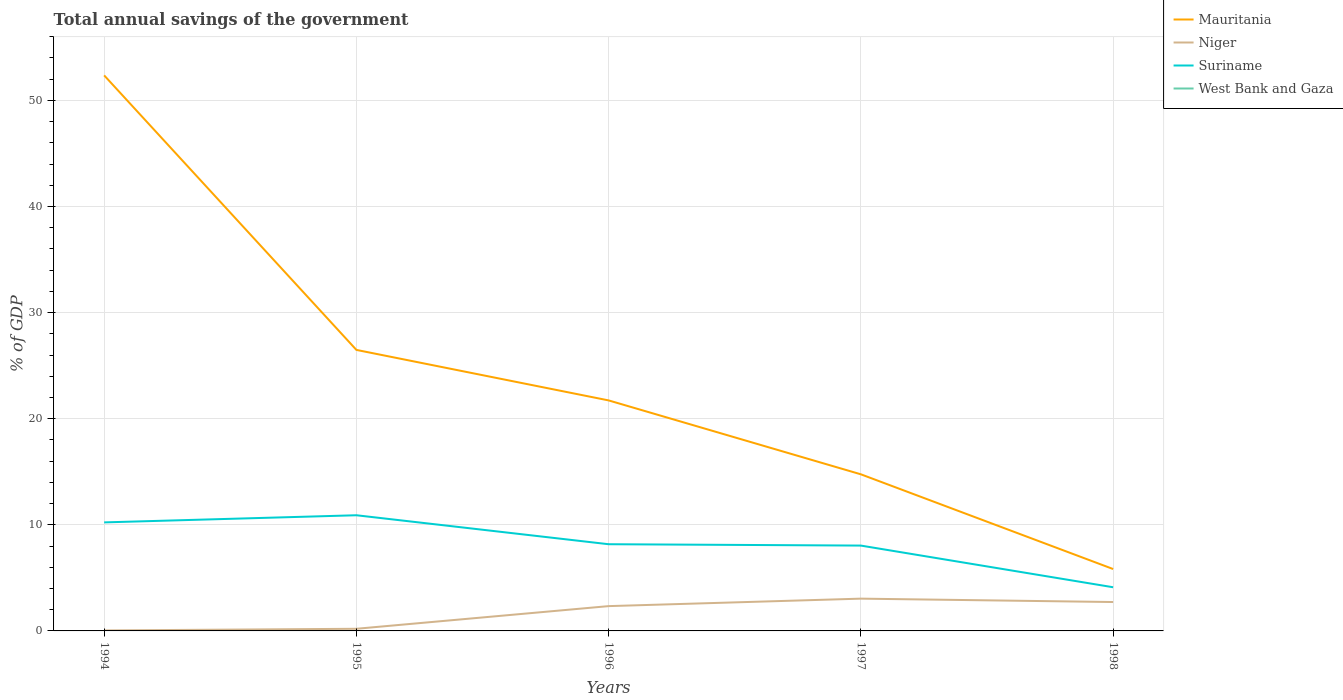How many different coloured lines are there?
Your response must be concise. 3. Across all years, what is the maximum total annual savings of the government in Suriname?
Your answer should be very brief. 4.12. What is the total total annual savings of the government in Suriname in the graph?
Offer a very short reply. 2.73. What is the difference between the highest and the second highest total annual savings of the government in Niger?
Offer a very short reply. 3. Is the total annual savings of the government in Mauritania strictly greater than the total annual savings of the government in Suriname over the years?
Provide a succinct answer. No. What is the difference between two consecutive major ticks on the Y-axis?
Offer a very short reply. 10. Are the values on the major ticks of Y-axis written in scientific E-notation?
Offer a very short reply. No. Does the graph contain any zero values?
Your answer should be very brief. Yes. How many legend labels are there?
Your answer should be very brief. 4. How are the legend labels stacked?
Ensure brevity in your answer.  Vertical. What is the title of the graph?
Keep it short and to the point. Total annual savings of the government. What is the label or title of the X-axis?
Offer a very short reply. Years. What is the label or title of the Y-axis?
Ensure brevity in your answer.  % of GDP. What is the % of GDP in Mauritania in 1994?
Provide a succinct answer. 52.35. What is the % of GDP in Niger in 1994?
Provide a succinct answer. 0.05. What is the % of GDP in Suriname in 1994?
Provide a succinct answer. 10.23. What is the % of GDP of Mauritania in 1995?
Ensure brevity in your answer.  26.48. What is the % of GDP in Niger in 1995?
Provide a succinct answer. 0.2. What is the % of GDP of Suriname in 1995?
Give a very brief answer. 10.9. What is the % of GDP in Mauritania in 1996?
Ensure brevity in your answer.  21.72. What is the % of GDP in Niger in 1996?
Keep it short and to the point. 2.34. What is the % of GDP of Suriname in 1996?
Your response must be concise. 8.17. What is the % of GDP in Mauritania in 1997?
Offer a very short reply. 14.76. What is the % of GDP of Niger in 1997?
Make the answer very short. 3.04. What is the % of GDP in Suriname in 1997?
Offer a very short reply. 8.04. What is the % of GDP of West Bank and Gaza in 1997?
Offer a terse response. 0. What is the % of GDP of Mauritania in 1998?
Offer a terse response. 5.83. What is the % of GDP in Niger in 1998?
Keep it short and to the point. 2.72. What is the % of GDP of Suriname in 1998?
Your response must be concise. 4.12. Across all years, what is the maximum % of GDP of Mauritania?
Keep it short and to the point. 52.35. Across all years, what is the maximum % of GDP in Niger?
Offer a very short reply. 3.04. Across all years, what is the maximum % of GDP in Suriname?
Make the answer very short. 10.9. Across all years, what is the minimum % of GDP of Mauritania?
Your answer should be compact. 5.83. Across all years, what is the minimum % of GDP in Niger?
Your answer should be compact. 0.05. Across all years, what is the minimum % of GDP of Suriname?
Your answer should be very brief. 4.12. What is the total % of GDP in Mauritania in the graph?
Your response must be concise. 121.15. What is the total % of GDP in Niger in the graph?
Keep it short and to the point. 8.35. What is the total % of GDP in Suriname in the graph?
Provide a short and direct response. 41.46. What is the difference between the % of GDP of Mauritania in 1994 and that in 1995?
Your response must be concise. 25.87. What is the difference between the % of GDP in Niger in 1994 and that in 1995?
Your answer should be compact. -0.16. What is the difference between the % of GDP in Suriname in 1994 and that in 1995?
Give a very brief answer. -0.67. What is the difference between the % of GDP of Mauritania in 1994 and that in 1996?
Make the answer very short. 30.63. What is the difference between the % of GDP in Niger in 1994 and that in 1996?
Provide a succinct answer. -2.29. What is the difference between the % of GDP of Suriname in 1994 and that in 1996?
Keep it short and to the point. 2.06. What is the difference between the % of GDP of Mauritania in 1994 and that in 1997?
Your answer should be very brief. 37.59. What is the difference between the % of GDP in Niger in 1994 and that in 1997?
Give a very brief answer. -3. What is the difference between the % of GDP of Suriname in 1994 and that in 1997?
Your answer should be very brief. 2.19. What is the difference between the % of GDP in Mauritania in 1994 and that in 1998?
Give a very brief answer. 46.52. What is the difference between the % of GDP of Niger in 1994 and that in 1998?
Your response must be concise. -2.68. What is the difference between the % of GDP in Suriname in 1994 and that in 1998?
Ensure brevity in your answer.  6.11. What is the difference between the % of GDP in Mauritania in 1995 and that in 1996?
Make the answer very short. 4.76. What is the difference between the % of GDP of Niger in 1995 and that in 1996?
Keep it short and to the point. -2.14. What is the difference between the % of GDP of Suriname in 1995 and that in 1996?
Your answer should be compact. 2.73. What is the difference between the % of GDP in Mauritania in 1995 and that in 1997?
Your answer should be very brief. 11.72. What is the difference between the % of GDP of Niger in 1995 and that in 1997?
Your response must be concise. -2.84. What is the difference between the % of GDP in Suriname in 1995 and that in 1997?
Provide a short and direct response. 2.86. What is the difference between the % of GDP in Mauritania in 1995 and that in 1998?
Provide a succinct answer. 20.65. What is the difference between the % of GDP of Niger in 1995 and that in 1998?
Provide a short and direct response. -2.52. What is the difference between the % of GDP in Suriname in 1995 and that in 1998?
Provide a succinct answer. 6.79. What is the difference between the % of GDP in Mauritania in 1996 and that in 1997?
Your answer should be very brief. 6.96. What is the difference between the % of GDP in Niger in 1996 and that in 1997?
Provide a succinct answer. -0.71. What is the difference between the % of GDP of Suriname in 1996 and that in 1997?
Offer a terse response. 0.13. What is the difference between the % of GDP in Mauritania in 1996 and that in 1998?
Your answer should be compact. 15.89. What is the difference between the % of GDP in Niger in 1996 and that in 1998?
Give a very brief answer. -0.39. What is the difference between the % of GDP of Suriname in 1996 and that in 1998?
Your response must be concise. 4.05. What is the difference between the % of GDP in Mauritania in 1997 and that in 1998?
Your answer should be compact. 8.93. What is the difference between the % of GDP in Niger in 1997 and that in 1998?
Keep it short and to the point. 0.32. What is the difference between the % of GDP in Suriname in 1997 and that in 1998?
Ensure brevity in your answer.  3.93. What is the difference between the % of GDP in Mauritania in 1994 and the % of GDP in Niger in 1995?
Offer a terse response. 52.15. What is the difference between the % of GDP in Mauritania in 1994 and the % of GDP in Suriname in 1995?
Keep it short and to the point. 41.45. What is the difference between the % of GDP of Niger in 1994 and the % of GDP of Suriname in 1995?
Provide a succinct answer. -10.86. What is the difference between the % of GDP in Mauritania in 1994 and the % of GDP in Niger in 1996?
Your response must be concise. 50.01. What is the difference between the % of GDP in Mauritania in 1994 and the % of GDP in Suriname in 1996?
Your response must be concise. 44.18. What is the difference between the % of GDP of Niger in 1994 and the % of GDP of Suriname in 1996?
Provide a succinct answer. -8.13. What is the difference between the % of GDP of Mauritania in 1994 and the % of GDP of Niger in 1997?
Your answer should be compact. 49.31. What is the difference between the % of GDP in Mauritania in 1994 and the % of GDP in Suriname in 1997?
Your response must be concise. 44.31. What is the difference between the % of GDP of Niger in 1994 and the % of GDP of Suriname in 1997?
Your answer should be compact. -8. What is the difference between the % of GDP of Mauritania in 1994 and the % of GDP of Niger in 1998?
Provide a short and direct response. 49.63. What is the difference between the % of GDP of Mauritania in 1994 and the % of GDP of Suriname in 1998?
Offer a very short reply. 48.24. What is the difference between the % of GDP of Niger in 1994 and the % of GDP of Suriname in 1998?
Make the answer very short. -4.07. What is the difference between the % of GDP in Mauritania in 1995 and the % of GDP in Niger in 1996?
Keep it short and to the point. 24.14. What is the difference between the % of GDP of Mauritania in 1995 and the % of GDP of Suriname in 1996?
Ensure brevity in your answer.  18.31. What is the difference between the % of GDP in Niger in 1995 and the % of GDP in Suriname in 1996?
Ensure brevity in your answer.  -7.97. What is the difference between the % of GDP of Mauritania in 1995 and the % of GDP of Niger in 1997?
Offer a terse response. 23.44. What is the difference between the % of GDP of Mauritania in 1995 and the % of GDP of Suriname in 1997?
Provide a succinct answer. 18.44. What is the difference between the % of GDP in Niger in 1995 and the % of GDP in Suriname in 1997?
Provide a succinct answer. -7.84. What is the difference between the % of GDP of Mauritania in 1995 and the % of GDP of Niger in 1998?
Ensure brevity in your answer.  23.76. What is the difference between the % of GDP in Mauritania in 1995 and the % of GDP in Suriname in 1998?
Your answer should be compact. 22.37. What is the difference between the % of GDP of Niger in 1995 and the % of GDP of Suriname in 1998?
Your answer should be very brief. -3.91. What is the difference between the % of GDP of Mauritania in 1996 and the % of GDP of Niger in 1997?
Offer a terse response. 18.68. What is the difference between the % of GDP in Mauritania in 1996 and the % of GDP in Suriname in 1997?
Offer a terse response. 13.68. What is the difference between the % of GDP of Niger in 1996 and the % of GDP of Suriname in 1997?
Keep it short and to the point. -5.7. What is the difference between the % of GDP of Mauritania in 1996 and the % of GDP of Niger in 1998?
Your response must be concise. 19. What is the difference between the % of GDP of Mauritania in 1996 and the % of GDP of Suriname in 1998?
Your response must be concise. 17.61. What is the difference between the % of GDP of Niger in 1996 and the % of GDP of Suriname in 1998?
Offer a very short reply. -1.78. What is the difference between the % of GDP of Mauritania in 1997 and the % of GDP of Niger in 1998?
Offer a very short reply. 12.03. What is the difference between the % of GDP of Mauritania in 1997 and the % of GDP of Suriname in 1998?
Give a very brief answer. 10.64. What is the difference between the % of GDP in Niger in 1997 and the % of GDP in Suriname in 1998?
Offer a very short reply. -1.07. What is the average % of GDP in Mauritania per year?
Your answer should be compact. 24.23. What is the average % of GDP in Niger per year?
Give a very brief answer. 1.67. What is the average % of GDP in Suriname per year?
Provide a succinct answer. 8.29. In the year 1994, what is the difference between the % of GDP in Mauritania and % of GDP in Niger?
Give a very brief answer. 52.31. In the year 1994, what is the difference between the % of GDP of Mauritania and % of GDP of Suriname?
Offer a very short reply. 42.12. In the year 1994, what is the difference between the % of GDP in Niger and % of GDP in Suriname?
Make the answer very short. -10.18. In the year 1995, what is the difference between the % of GDP of Mauritania and % of GDP of Niger?
Give a very brief answer. 26.28. In the year 1995, what is the difference between the % of GDP in Mauritania and % of GDP in Suriname?
Keep it short and to the point. 15.58. In the year 1995, what is the difference between the % of GDP of Niger and % of GDP of Suriname?
Offer a terse response. -10.7. In the year 1996, what is the difference between the % of GDP in Mauritania and % of GDP in Niger?
Provide a succinct answer. 19.38. In the year 1996, what is the difference between the % of GDP in Mauritania and % of GDP in Suriname?
Provide a short and direct response. 13.55. In the year 1996, what is the difference between the % of GDP in Niger and % of GDP in Suriname?
Your response must be concise. -5.83. In the year 1997, what is the difference between the % of GDP of Mauritania and % of GDP of Niger?
Give a very brief answer. 11.72. In the year 1997, what is the difference between the % of GDP in Mauritania and % of GDP in Suriname?
Keep it short and to the point. 6.72. In the year 1997, what is the difference between the % of GDP in Niger and % of GDP in Suriname?
Provide a succinct answer. -5. In the year 1998, what is the difference between the % of GDP in Mauritania and % of GDP in Niger?
Your answer should be compact. 3.11. In the year 1998, what is the difference between the % of GDP of Mauritania and % of GDP of Suriname?
Your answer should be very brief. 1.72. In the year 1998, what is the difference between the % of GDP in Niger and % of GDP in Suriname?
Your response must be concise. -1.39. What is the ratio of the % of GDP of Mauritania in 1994 to that in 1995?
Ensure brevity in your answer.  1.98. What is the ratio of the % of GDP in Niger in 1994 to that in 1995?
Give a very brief answer. 0.22. What is the ratio of the % of GDP in Suriname in 1994 to that in 1995?
Your answer should be very brief. 0.94. What is the ratio of the % of GDP in Mauritania in 1994 to that in 1996?
Provide a succinct answer. 2.41. What is the ratio of the % of GDP in Niger in 1994 to that in 1996?
Provide a short and direct response. 0.02. What is the ratio of the % of GDP in Suriname in 1994 to that in 1996?
Offer a very short reply. 1.25. What is the ratio of the % of GDP in Mauritania in 1994 to that in 1997?
Offer a very short reply. 3.55. What is the ratio of the % of GDP in Niger in 1994 to that in 1997?
Your response must be concise. 0.01. What is the ratio of the % of GDP of Suriname in 1994 to that in 1997?
Your answer should be compact. 1.27. What is the ratio of the % of GDP in Mauritania in 1994 to that in 1998?
Make the answer very short. 8.98. What is the ratio of the % of GDP of Niger in 1994 to that in 1998?
Your answer should be very brief. 0.02. What is the ratio of the % of GDP in Suriname in 1994 to that in 1998?
Your response must be concise. 2.49. What is the ratio of the % of GDP in Mauritania in 1995 to that in 1996?
Your response must be concise. 1.22. What is the ratio of the % of GDP in Niger in 1995 to that in 1996?
Provide a short and direct response. 0.09. What is the ratio of the % of GDP of Suriname in 1995 to that in 1996?
Your response must be concise. 1.33. What is the ratio of the % of GDP of Mauritania in 1995 to that in 1997?
Your response must be concise. 1.79. What is the ratio of the % of GDP of Niger in 1995 to that in 1997?
Offer a terse response. 0.07. What is the ratio of the % of GDP in Suriname in 1995 to that in 1997?
Offer a terse response. 1.36. What is the ratio of the % of GDP of Mauritania in 1995 to that in 1998?
Ensure brevity in your answer.  4.54. What is the ratio of the % of GDP of Niger in 1995 to that in 1998?
Give a very brief answer. 0.07. What is the ratio of the % of GDP of Suriname in 1995 to that in 1998?
Ensure brevity in your answer.  2.65. What is the ratio of the % of GDP of Mauritania in 1996 to that in 1997?
Provide a succinct answer. 1.47. What is the ratio of the % of GDP in Niger in 1996 to that in 1997?
Keep it short and to the point. 0.77. What is the ratio of the % of GDP in Mauritania in 1996 to that in 1998?
Make the answer very short. 3.72. What is the ratio of the % of GDP of Niger in 1996 to that in 1998?
Offer a very short reply. 0.86. What is the ratio of the % of GDP in Suriname in 1996 to that in 1998?
Keep it short and to the point. 1.99. What is the ratio of the % of GDP of Mauritania in 1997 to that in 1998?
Your answer should be compact. 2.53. What is the ratio of the % of GDP in Niger in 1997 to that in 1998?
Offer a very short reply. 1.12. What is the ratio of the % of GDP in Suriname in 1997 to that in 1998?
Give a very brief answer. 1.95. What is the difference between the highest and the second highest % of GDP of Mauritania?
Make the answer very short. 25.87. What is the difference between the highest and the second highest % of GDP in Niger?
Your answer should be very brief. 0.32. What is the difference between the highest and the second highest % of GDP in Suriname?
Offer a very short reply. 0.67. What is the difference between the highest and the lowest % of GDP in Mauritania?
Keep it short and to the point. 46.52. What is the difference between the highest and the lowest % of GDP in Niger?
Provide a succinct answer. 3. What is the difference between the highest and the lowest % of GDP in Suriname?
Your answer should be very brief. 6.79. 